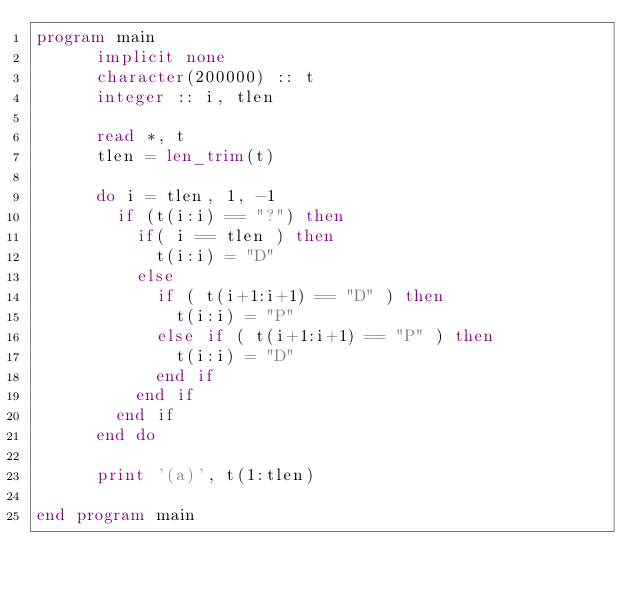Convert code to text. <code><loc_0><loc_0><loc_500><loc_500><_FORTRAN_>program main
      implicit none
      character(200000) :: t
      integer :: i, tlen

      read *, t
      tlen = len_trim(t)

      do i = tlen, 1, -1
        if (t(i:i) == "?") then
          if( i == tlen ) then
            t(i:i) = "D"
          else
            if ( t(i+1:i+1) == "D" ) then
              t(i:i) = "P"
            else if ( t(i+1:i+1) == "P" ) then
              t(i:i) = "D"
            end if
          end if
        end if
      end do

      print '(a)', t(1:tlen)

end program main
</code> 